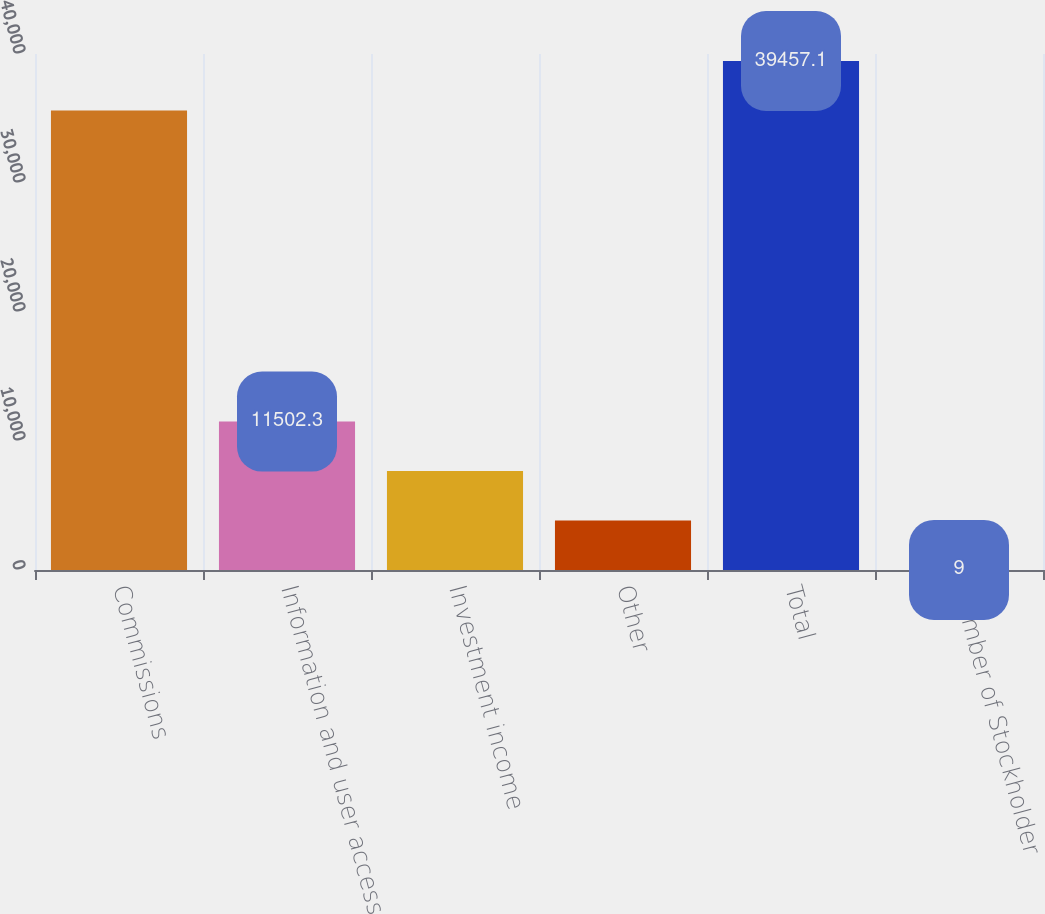<chart> <loc_0><loc_0><loc_500><loc_500><bar_chart><fcel>Commissions<fcel>Information and user access<fcel>Investment income<fcel>Other<fcel>Total<fcel>Number of Stockholder<nl><fcel>35626<fcel>11502.3<fcel>7671.2<fcel>3840.1<fcel>39457.1<fcel>9<nl></chart> 